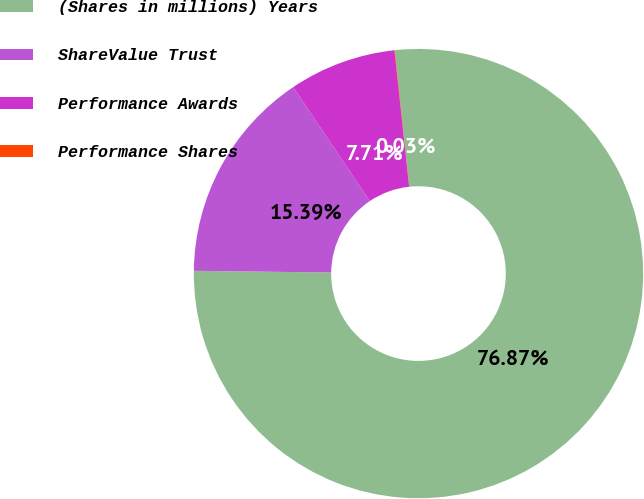Convert chart to OTSL. <chart><loc_0><loc_0><loc_500><loc_500><pie_chart><fcel>(Shares in millions) Years<fcel>ShareValue Trust<fcel>Performance Awards<fcel>Performance Shares<nl><fcel>76.87%<fcel>15.39%<fcel>7.71%<fcel>0.03%<nl></chart> 